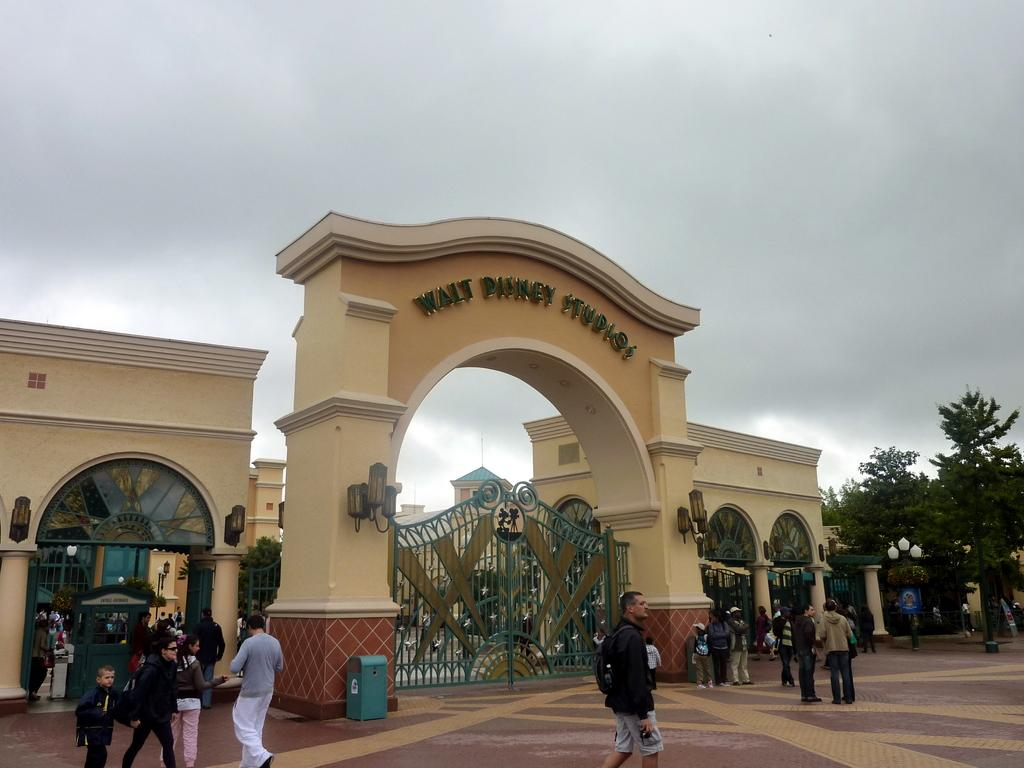Provide a one-sentence caption for the provided image. the entrance to the Walt Disney Studios and closed gate. 